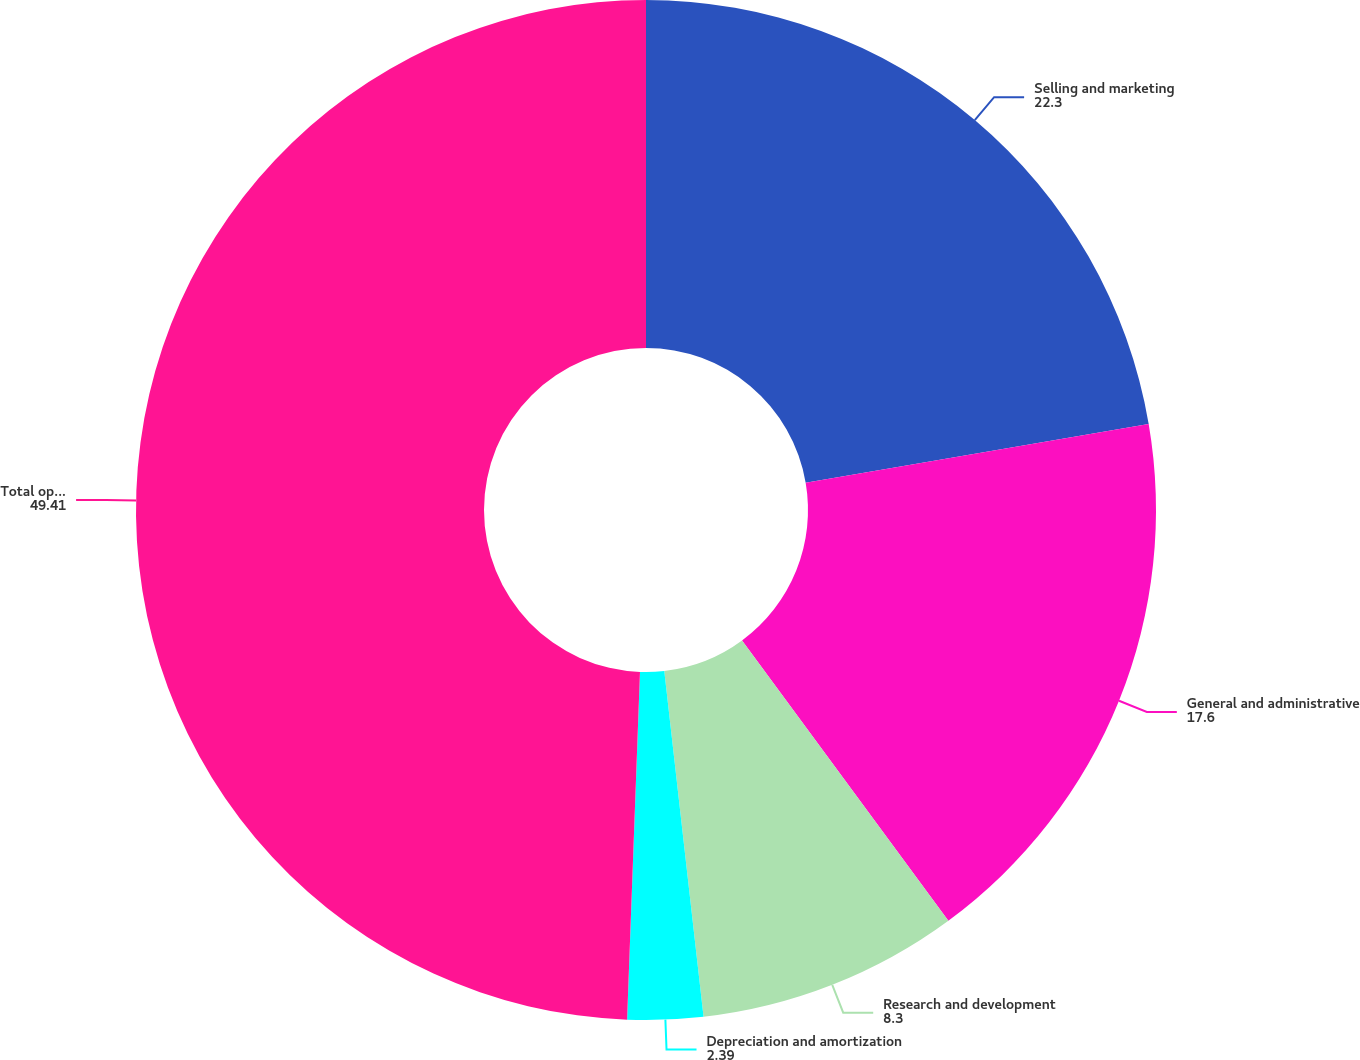<chart> <loc_0><loc_0><loc_500><loc_500><pie_chart><fcel>Selling and marketing<fcel>General and administrative<fcel>Research and development<fcel>Depreciation and amortization<fcel>Total operating expenses (1)<nl><fcel>22.3%<fcel>17.6%<fcel>8.3%<fcel>2.39%<fcel>49.41%<nl></chart> 